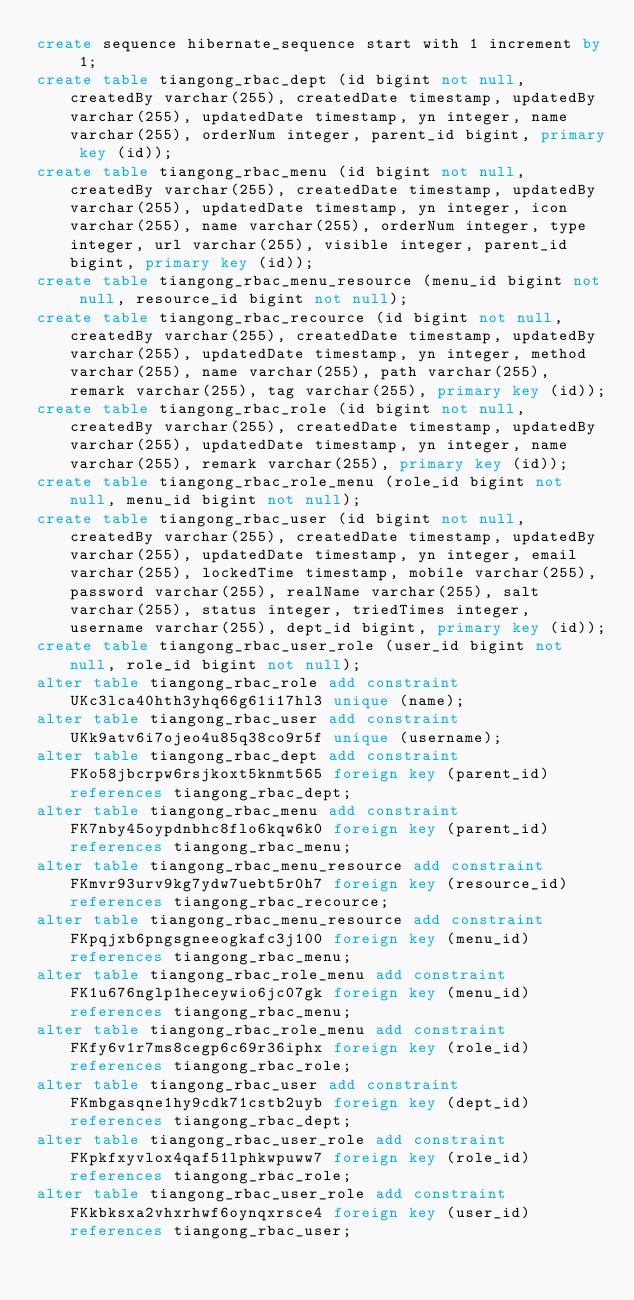<code> <loc_0><loc_0><loc_500><loc_500><_SQL_>create sequence hibernate_sequence start with 1 increment by 1;
create table tiangong_rbac_dept (id bigint not null, createdBy varchar(255), createdDate timestamp, updatedBy varchar(255), updatedDate timestamp, yn integer, name varchar(255), orderNum integer, parent_id bigint, primary key (id));
create table tiangong_rbac_menu (id bigint not null, createdBy varchar(255), createdDate timestamp, updatedBy varchar(255), updatedDate timestamp, yn integer, icon varchar(255), name varchar(255), orderNum integer, type integer, url varchar(255), visible integer, parent_id bigint, primary key (id));
create table tiangong_rbac_menu_resource (menu_id bigint not null, resource_id bigint not null);
create table tiangong_rbac_recource (id bigint not null, createdBy varchar(255), createdDate timestamp, updatedBy varchar(255), updatedDate timestamp, yn integer, method varchar(255), name varchar(255), path varchar(255), remark varchar(255), tag varchar(255), primary key (id));
create table tiangong_rbac_role (id bigint not null, createdBy varchar(255), createdDate timestamp, updatedBy varchar(255), updatedDate timestamp, yn integer, name varchar(255), remark varchar(255), primary key (id));
create table tiangong_rbac_role_menu (role_id bigint not null, menu_id bigint not null);
create table tiangong_rbac_user (id bigint not null, createdBy varchar(255), createdDate timestamp, updatedBy varchar(255), updatedDate timestamp, yn integer, email varchar(255), lockedTime timestamp, mobile varchar(255), password varchar(255), realName varchar(255), salt varchar(255), status integer, triedTimes integer, username varchar(255), dept_id bigint, primary key (id));
create table tiangong_rbac_user_role (user_id bigint not null, role_id bigint not null);
alter table tiangong_rbac_role add constraint UKc3lca40hth3yhq66g61i17hl3 unique (name);
alter table tiangong_rbac_user add constraint UKk9atv6i7ojeo4u85q38co9r5f unique (username);
alter table tiangong_rbac_dept add constraint FKo58jbcrpw6rsjkoxt5knmt565 foreign key (parent_id) references tiangong_rbac_dept;
alter table tiangong_rbac_menu add constraint FK7nby45oypdnbhc8flo6kqw6k0 foreign key (parent_id) references tiangong_rbac_menu;
alter table tiangong_rbac_menu_resource add constraint FKmvr93urv9kg7ydw7uebt5r0h7 foreign key (resource_id) references tiangong_rbac_recource;
alter table tiangong_rbac_menu_resource add constraint FKpqjxb6pngsgneeogkafc3j100 foreign key (menu_id) references tiangong_rbac_menu;
alter table tiangong_rbac_role_menu add constraint FK1u676nglp1heceywio6jc07gk foreign key (menu_id) references tiangong_rbac_menu;
alter table tiangong_rbac_role_menu add constraint FKfy6v1r7ms8cegp6c69r36iphx foreign key (role_id) references tiangong_rbac_role;
alter table tiangong_rbac_user add constraint FKmbgasqne1hy9cdk71cstb2uyb foreign key (dept_id) references tiangong_rbac_dept;
alter table tiangong_rbac_user_role add constraint FKpkfxyvlox4qaf51lphkwpuww7 foreign key (role_id) references tiangong_rbac_role;
alter table tiangong_rbac_user_role add constraint FKkbksxa2vhxrhwf6oynqxrsce4 foreign key (user_id) references tiangong_rbac_user;</code> 